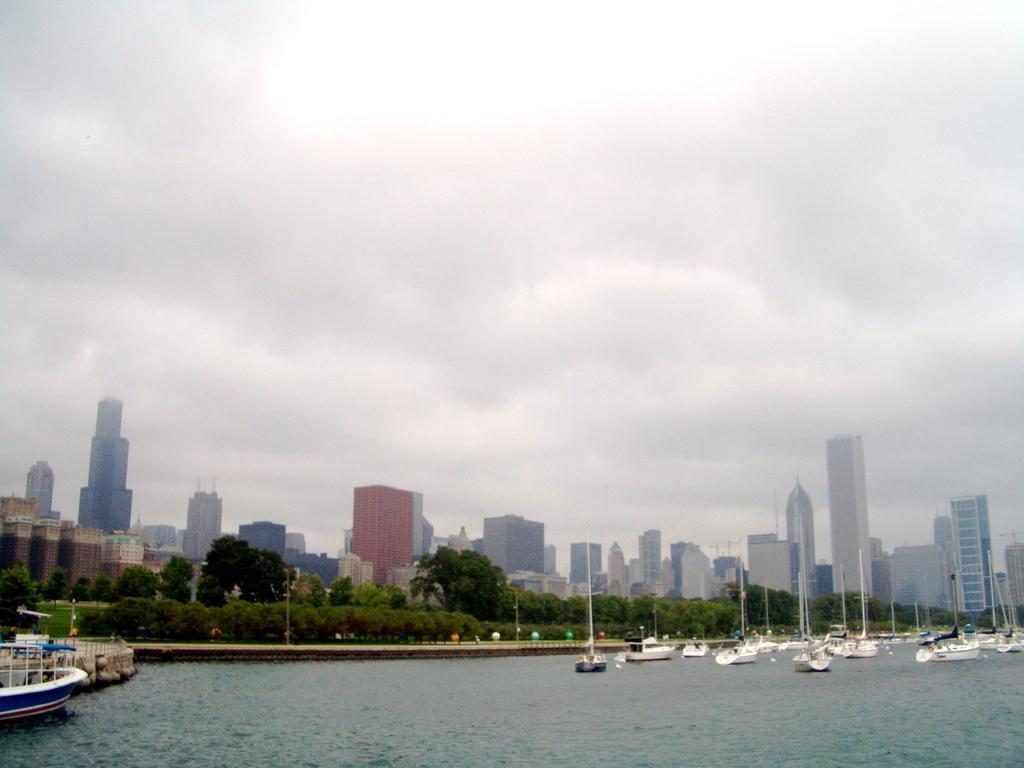What is on the water surface in the image? There are boats on the water surface in the image. What can be seen in the background of the image? There are trees and buildings visible in the background of the image. What type of square can be seen in the image? There is no square present in the image. Can you tell me the income of the people in the boats in the image? There is no information about the income of the people in the boats in the image. 